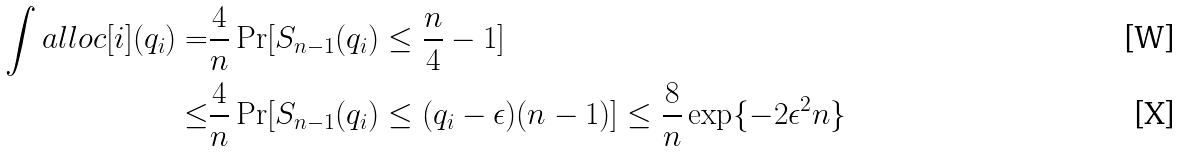<formula> <loc_0><loc_0><loc_500><loc_500>\int a l l o c [ i ] ( q _ { i } ) = & \frac { 4 } { n } \Pr [ S _ { n - 1 } ( q _ { i } ) \leq \frac { n } { 4 } - 1 ] \\ \leq & \frac { 4 } { n } \Pr [ S _ { n - 1 } ( q _ { i } ) \leq ( q _ { i } - \epsilon ) ( n - 1 ) ] \leq \frac { 8 } { n } \exp \{ - 2 \epsilon ^ { 2 } n \}</formula> 